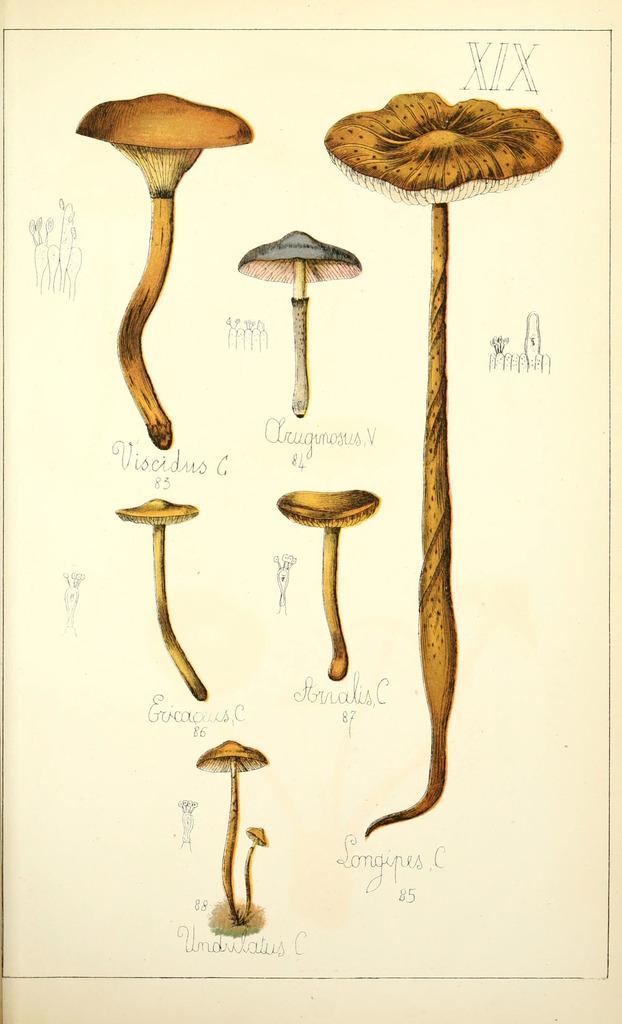Can you describe this image briefly? In this picture we can see planets with names of it and some symbols. 